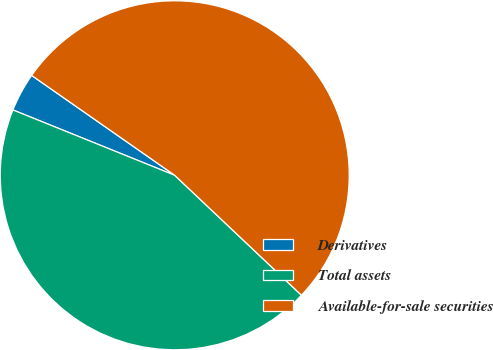Convert chart. <chart><loc_0><loc_0><loc_500><loc_500><pie_chart><fcel>Derivatives<fcel>Total assets<fcel>Available-for-sale securities<nl><fcel>3.59%<fcel>44.05%<fcel>52.36%<nl></chart> 